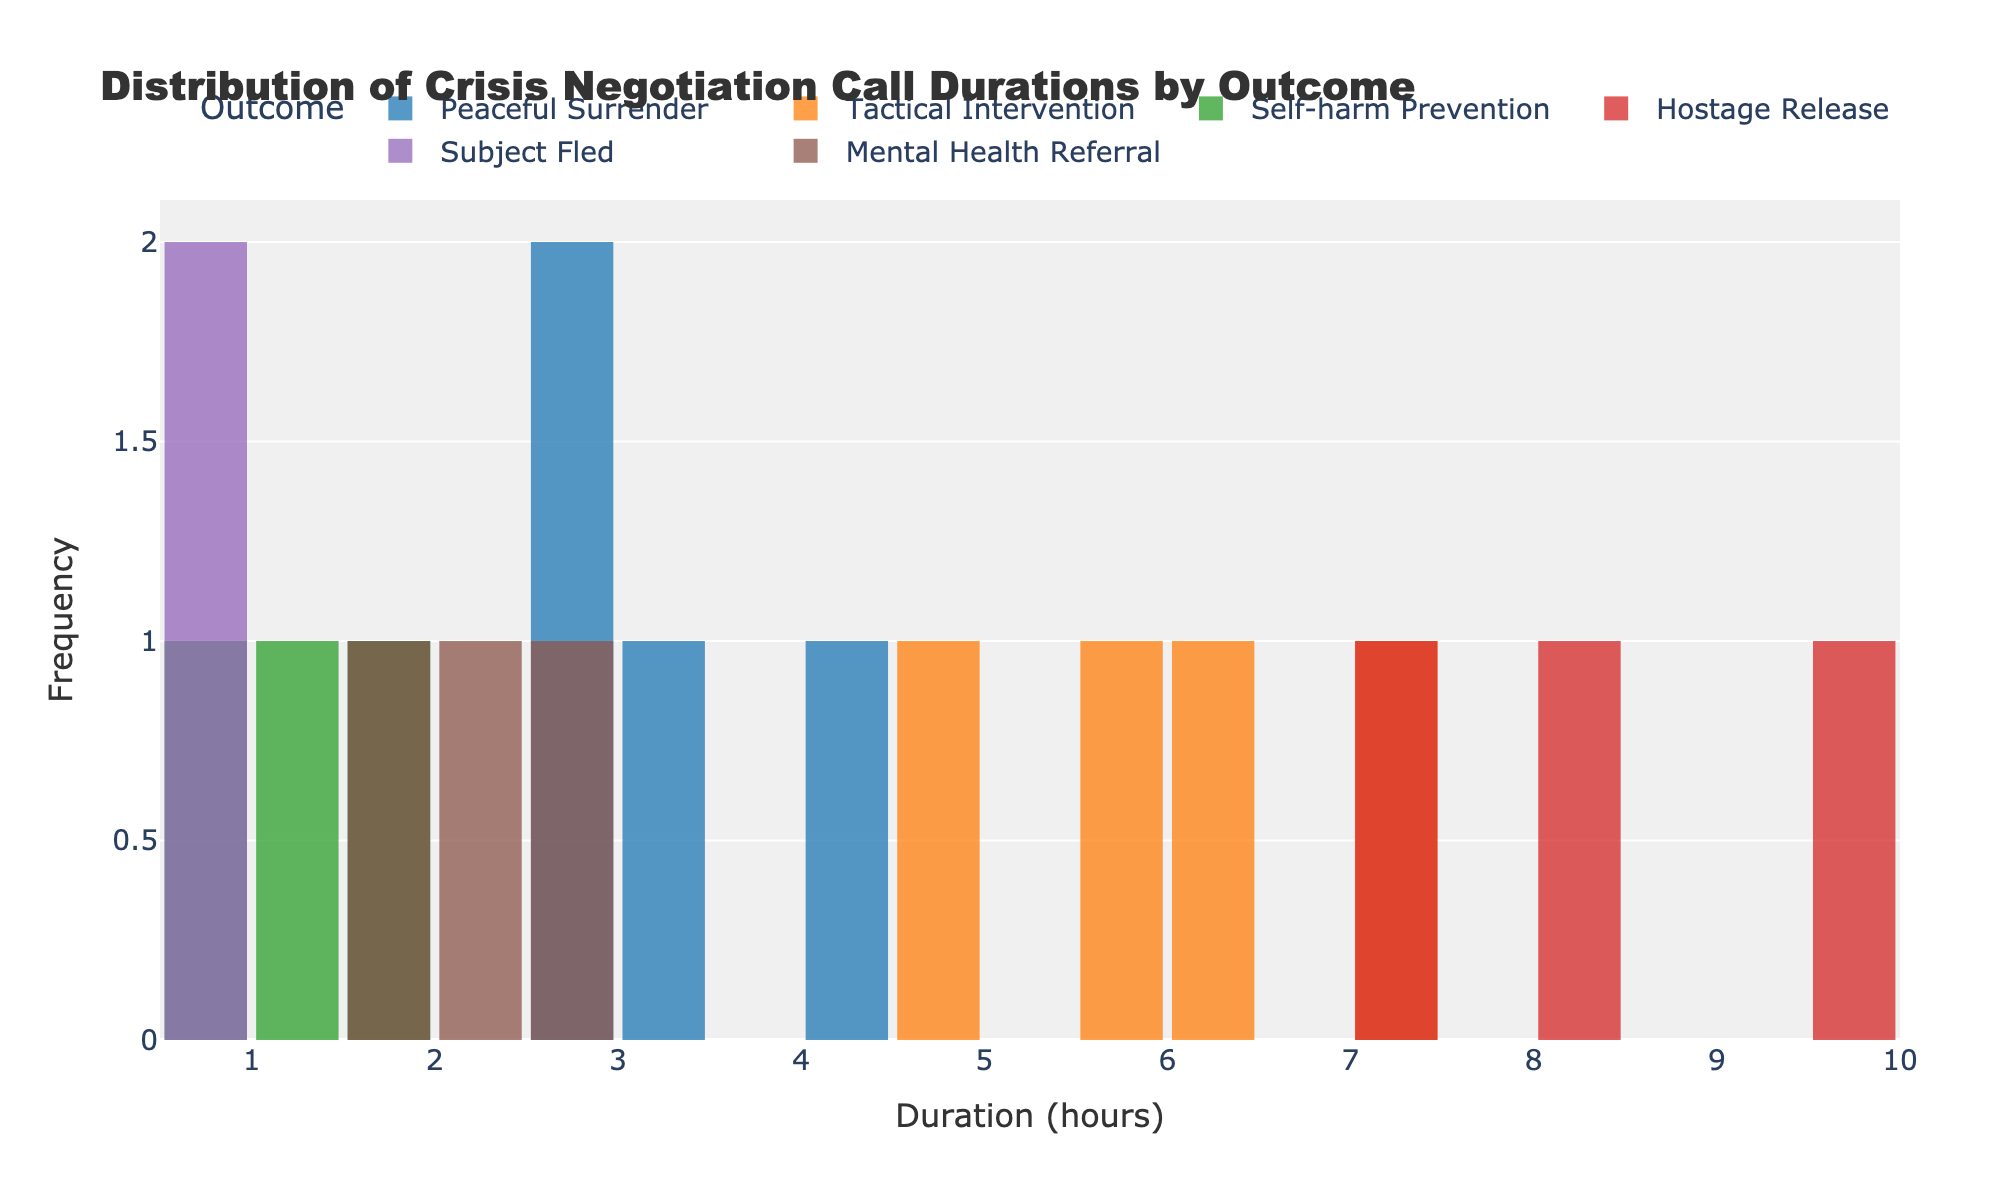What is the title of the histogram? The title is usually found at the top of the figure and provides a summary of the content depicted. In this case, it is directly stated in the layout section of the code.
Answer: Distribution of Crisis Negotiation Call Durations by Outcome What is the x-axis representing? The x-axis in a histogram typically represents the bins or intervals of the measurement being analyzed. Here, it clearly represents the 'Duration (hours)' of crisis negotiation calls.
Answer: Duration (hours) Which outcome category has the highest frequency of call durations near 1 hour? Identify the bar with the highest peak around the 1-hour mark and note which outcome category it is. The `Self-harm Prevention` category shows the highest frequency around this duration.
Answer: Self-harm Prevention Which outcome takes the longest average call duration? To find the longest average call duration, observe which outcome has bars more concentrated towards the higher end of the duration scale. The `Hostage Release` outcome is mostly distributed in higher durations (8.4 and 9.7 hours).
Answer: Hostage Release How many outcome categories are presented in the histogram? Count the distinct categories presented in the legend of the histogram, each represented by different colors. There are 6 categories: Peaceful Surrender, Tactical Intervention, Self-harm Prevention, Hostage Release, Subject Fled, and Mental Health Referral.
Answer: 6 Which two outcomes have overlapping call duration distributions? Look for bars from different categories that share the same positions along the x-axis. The `Peaceful Surrender` and `Mental Health Referral` outcomes have overlapping distributions around 2-3 hours.
Answer: Peaceful Surrender and Mental Health Referral What is the range of durations for the `Tactical Intervention` outcome? Examine the start and end of the bins where the `Tactical Intervention` bars are plotted. They range from 4.8 to 7.2 hours.
Answer: 4.8 to 7.2 hours What is the least frequent duration for the `Subject Fled` outcome? Identify the duration(s) where the `Subject Fled` outcome has the least frequency. The `Subject Fled` outcome only has values at 0.5 and 0.7 hours.
Answer: 0.5 and 0.7 hours Which outcome encounters durations less than 1 hour? Focus on the histogram bars that fall under the less than 1-hour range and identify the corresponding outcome. The `Self-harm Prevention` and `Subject Fled` outcomes have durations less than 1 hour.
Answer: Self-harm Prevention and Subject Fled 